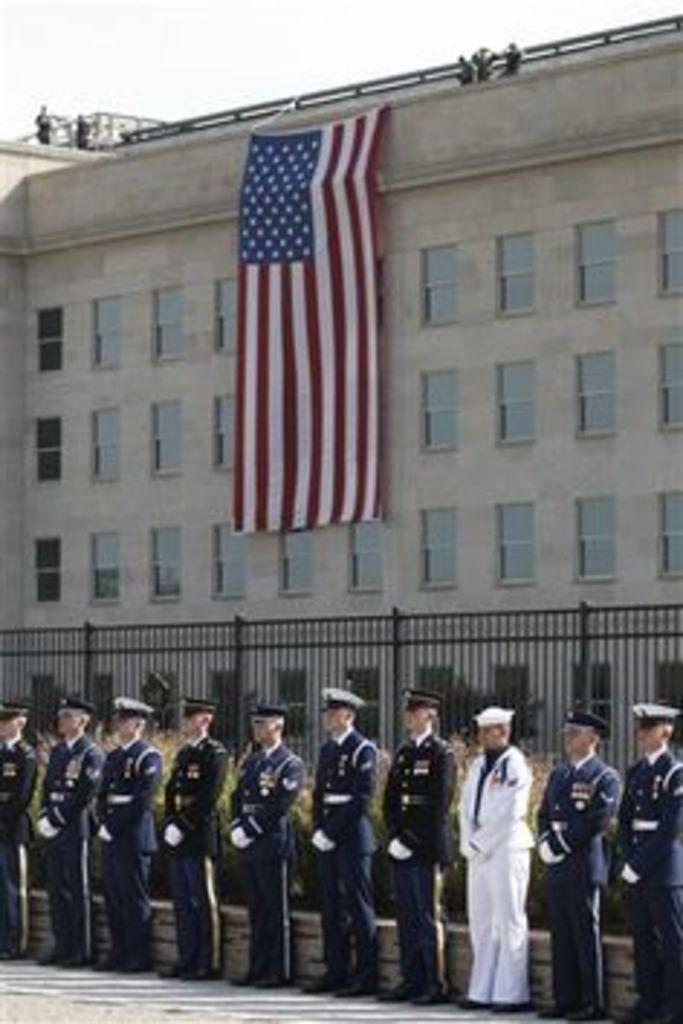Can you describe this image briefly? In this picture we can see the officers were wearing the same dress except one. In the bottom right there is a man who is wearing white dress. Behind them we can see the plants and black fencing. In the background there is a flag on the building. At the top of the building we can see some people were standing. At the top there is a sky. 